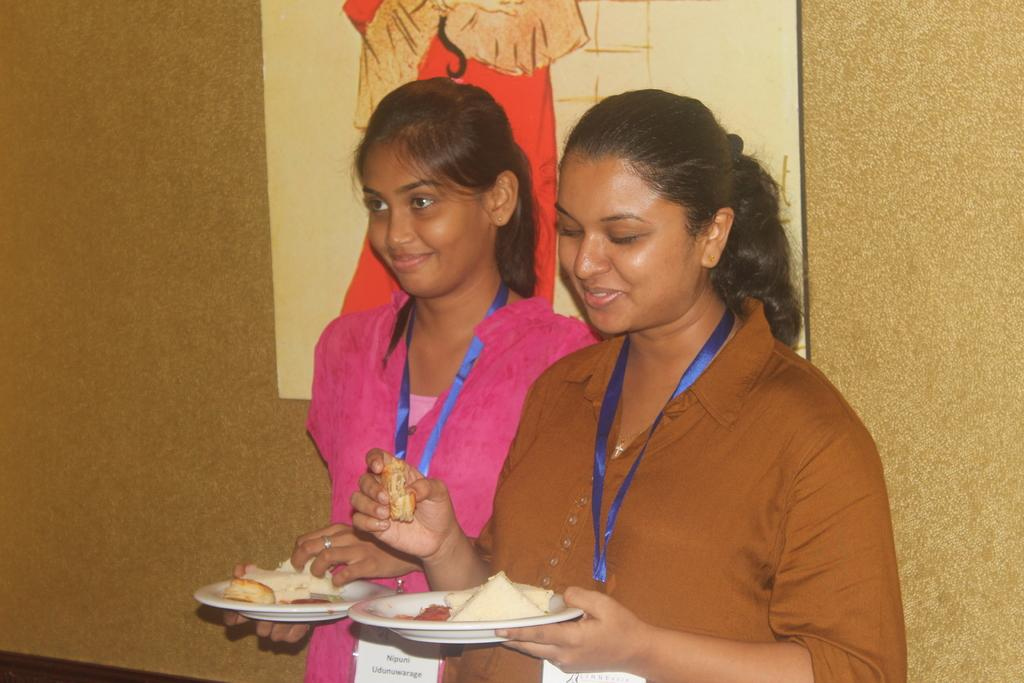How many people are in the image? There are two women in the image. What are the women doing in the image? The women are standing and holding a plate. What is on the plate that the women are holding? The plate has eatables on it. What can be seen on the wall behind the women? There is an image attached to the wall behind the women. What type of learning is the authority figure teaching in the image? There is no authority figure or learning activity depicted in the image; it features two women holding a plate with eatables. 